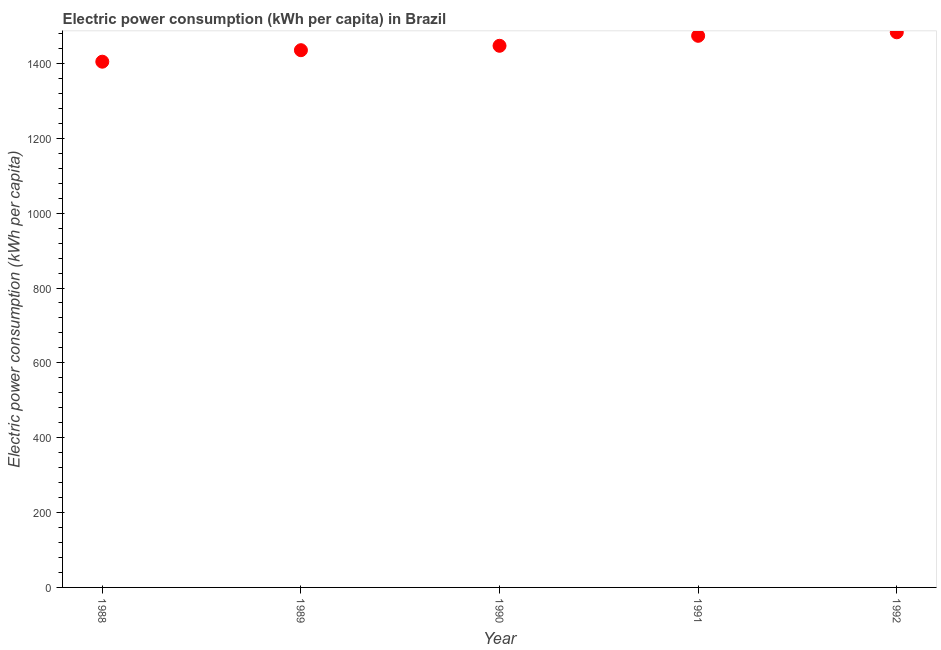What is the electric power consumption in 1991?
Your answer should be compact. 1473.89. Across all years, what is the maximum electric power consumption?
Give a very brief answer. 1483.3. Across all years, what is the minimum electric power consumption?
Give a very brief answer. 1404.74. In which year was the electric power consumption maximum?
Give a very brief answer. 1992. In which year was the electric power consumption minimum?
Make the answer very short. 1988. What is the sum of the electric power consumption?
Keep it short and to the point. 7244.66. What is the difference between the electric power consumption in 1988 and 1989?
Offer a terse response. -30.74. What is the average electric power consumption per year?
Keep it short and to the point. 1448.93. What is the median electric power consumption?
Your response must be concise. 1447.26. In how many years, is the electric power consumption greater than 560 kWh per capita?
Offer a very short reply. 5. Do a majority of the years between 1988 and 1989 (inclusive) have electric power consumption greater than 40 kWh per capita?
Provide a succinct answer. Yes. What is the ratio of the electric power consumption in 1990 to that in 1991?
Offer a terse response. 0.98. Is the difference between the electric power consumption in 1988 and 1992 greater than the difference between any two years?
Offer a terse response. Yes. What is the difference between the highest and the second highest electric power consumption?
Your answer should be compact. 9.4. What is the difference between the highest and the lowest electric power consumption?
Provide a short and direct response. 78.56. In how many years, is the electric power consumption greater than the average electric power consumption taken over all years?
Give a very brief answer. 2. Does the electric power consumption monotonically increase over the years?
Offer a terse response. Yes. Are the values on the major ticks of Y-axis written in scientific E-notation?
Your response must be concise. No. Does the graph contain grids?
Offer a very short reply. No. What is the title of the graph?
Give a very brief answer. Electric power consumption (kWh per capita) in Brazil. What is the label or title of the X-axis?
Your answer should be compact. Year. What is the label or title of the Y-axis?
Provide a succinct answer. Electric power consumption (kWh per capita). What is the Electric power consumption (kWh per capita) in 1988?
Your response must be concise. 1404.74. What is the Electric power consumption (kWh per capita) in 1989?
Offer a terse response. 1435.48. What is the Electric power consumption (kWh per capita) in 1990?
Keep it short and to the point. 1447.26. What is the Electric power consumption (kWh per capita) in 1991?
Your answer should be very brief. 1473.89. What is the Electric power consumption (kWh per capita) in 1992?
Keep it short and to the point. 1483.3. What is the difference between the Electric power consumption (kWh per capita) in 1988 and 1989?
Your answer should be very brief. -30.74. What is the difference between the Electric power consumption (kWh per capita) in 1988 and 1990?
Your response must be concise. -42.52. What is the difference between the Electric power consumption (kWh per capita) in 1988 and 1991?
Ensure brevity in your answer.  -69.16. What is the difference between the Electric power consumption (kWh per capita) in 1988 and 1992?
Your answer should be compact. -78.56. What is the difference between the Electric power consumption (kWh per capita) in 1989 and 1990?
Make the answer very short. -11.78. What is the difference between the Electric power consumption (kWh per capita) in 1989 and 1991?
Give a very brief answer. -38.42. What is the difference between the Electric power consumption (kWh per capita) in 1989 and 1992?
Provide a short and direct response. -47.82. What is the difference between the Electric power consumption (kWh per capita) in 1990 and 1991?
Provide a short and direct response. -26.63. What is the difference between the Electric power consumption (kWh per capita) in 1990 and 1992?
Your answer should be very brief. -36.04. What is the difference between the Electric power consumption (kWh per capita) in 1991 and 1992?
Your answer should be compact. -9.4. What is the ratio of the Electric power consumption (kWh per capita) in 1988 to that in 1989?
Your answer should be compact. 0.98. What is the ratio of the Electric power consumption (kWh per capita) in 1988 to that in 1991?
Provide a short and direct response. 0.95. What is the ratio of the Electric power consumption (kWh per capita) in 1988 to that in 1992?
Give a very brief answer. 0.95. What is the ratio of the Electric power consumption (kWh per capita) in 1989 to that in 1990?
Your answer should be very brief. 0.99. What is the ratio of the Electric power consumption (kWh per capita) in 1989 to that in 1991?
Ensure brevity in your answer.  0.97. What is the ratio of the Electric power consumption (kWh per capita) in 1990 to that in 1991?
Ensure brevity in your answer.  0.98. What is the ratio of the Electric power consumption (kWh per capita) in 1990 to that in 1992?
Your response must be concise. 0.98. 